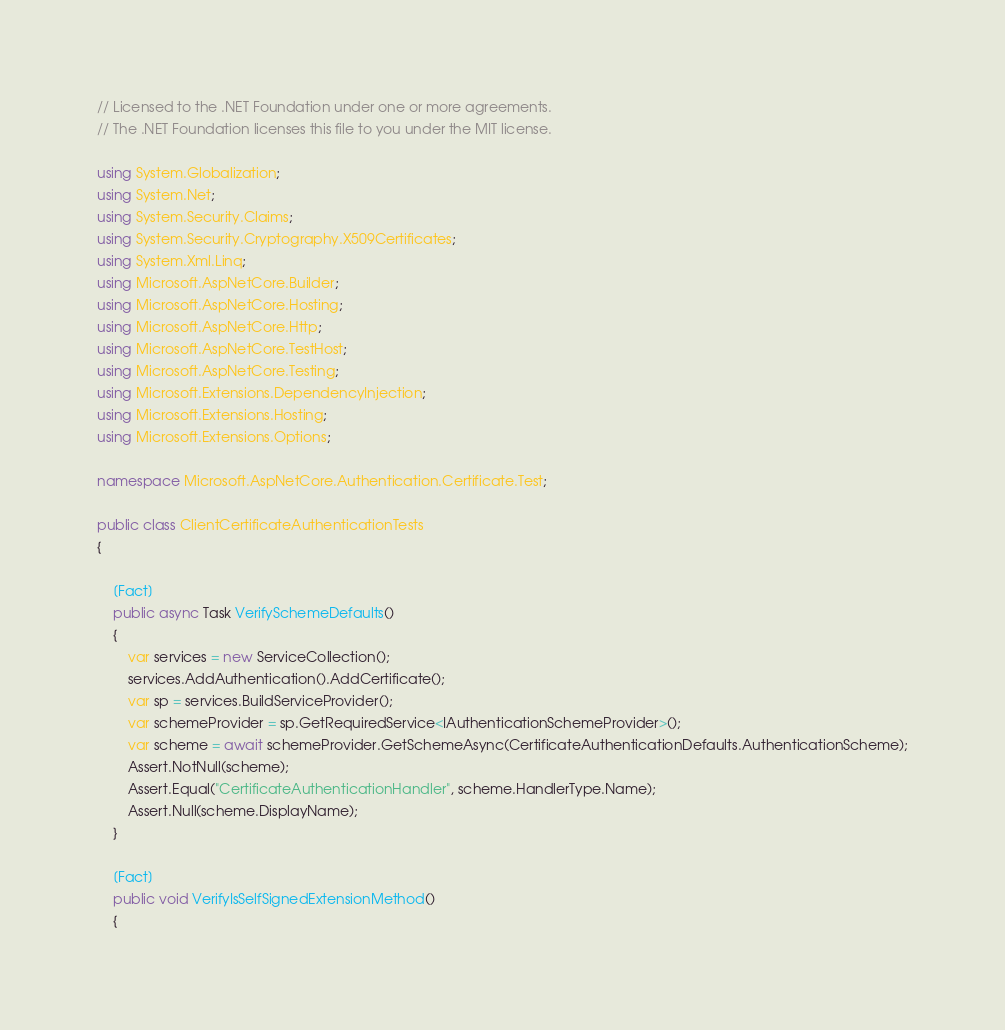<code> <loc_0><loc_0><loc_500><loc_500><_C#_>// Licensed to the .NET Foundation under one or more agreements.
// The .NET Foundation licenses this file to you under the MIT license.

using System.Globalization;
using System.Net;
using System.Security.Claims;
using System.Security.Cryptography.X509Certificates;
using System.Xml.Linq;
using Microsoft.AspNetCore.Builder;
using Microsoft.AspNetCore.Hosting;
using Microsoft.AspNetCore.Http;
using Microsoft.AspNetCore.TestHost;
using Microsoft.AspNetCore.Testing;
using Microsoft.Extensions.DependencyInjection;
using Microsoft.Extensions.Hosting;
using Microsoft.Extensions.Options;

namespace Microsoft.AspNetCore.Authentication.Certificate.Test;

public class ClientCertificateAuthenticationTests
{

    [Fact]
    public async Task VerifySchemeDefaults()
    {
        var services = new ServiceCollection();
        services.AddAuthentication().AddCertificate();
        var sp = services.BuildServiceProvider();
        var schemeProvider = sp.GetRequiredService<IAuthenticationSchemeProvider>();
        var scheme = await schemeProvider.GetSchemeAsync(CertificateAuthenticationDefaults.AuthenticationScheme);
        Assert.NotNull(scheme);
        Assert.Equal("CertificateAuthenticationHandler", scheme.HandlerType.Name);
        Assert.Null(scheme.DisplayName);
    }

    [Fact]
    public void VerifyIsSelfSignedExtensionMethod()
    {</code> 